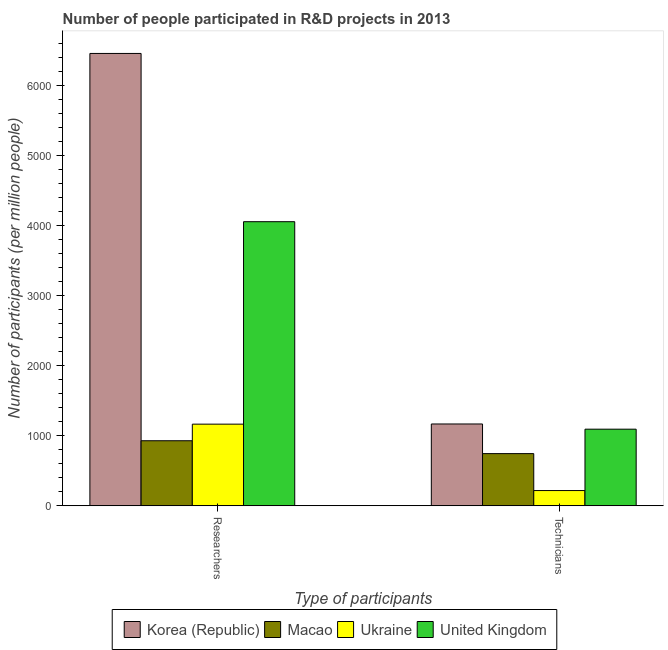How many different coloured bars are there?
Provide a succinct answer. 4. How many groups of bars are there?
Your answer should be compact. 2. How many bars are there on the 1st tick from the left?
Offer a terse response. 4. How many bars are there on the 1st tick from the right?
Keep it short and to the point. 4. What is the label of the 1st group of bars from the left?
Offer a terse response. Researchers. What is the number of researchers in Korea (Republic)?
Your answer should be very brief. 6456.63. Across all countries, what is the maximum number of researchers?
Provide a succinct answer. 6456.63. Across all countries, what is the minimum number of researchers?
Offer a very short reply. 928.25. In which country was the number of technicians minimum?
Provide a short and direct response. Ukraine. What is the total number of technicians in the graph?
Ensure brevity in your answer.  3223.07. What is the difference between the number of technicians in Macao and that in United Kingdom?
Your response must be concise. -348.83. What is the difference between the number of researchers in Ukraine and the number of technicians in United Kingdom?
Offer a very short reply. 71.71. What is the average number of researchers per country?
Offer a terse response. 3151.29. What is the difference between the number of researchers and number of technicians in United Kingdom?
Provide a short and direct response. 2961.63. In how many countries, is the number of researchers greater than 2600 ?
Make the answer very short. 2. What is the ratio of the number of technicians in Macao to that in Korea (Republic)?
Provide a short and direct response. 0.64. Is the number of researchers in Ukraine less than that in Macao?
Offer a terse response. No. In how many countries, is the number of researchers greater than the average number of researchers taken over all countries?
Provide a short and direct response. 2. What does the 4th bar from the left in Researchers represents?
Your response must be concise. United Kingdom. What does the 2nd bar from the right in Technicians represents?
Your response must be concise. Ukraine. How many bars are there?
Make the answer very short. 8. Are the values on the major ticks of Y-axis written in scientific E-notation?
Provide a succinct answer. No. Does the graph contain any zero values?
Your answer should be very brief. No. Does the graph contain grids?
Provide a succinct answer. No. Where does the legend appear in the graph?
Provide a succinct answer. Bottom center. How many legend labels are there?
Ensure brevity in your answer.  4. How are the legend labels stacked?
Offer a very short reply. Horizontal. What is the title of the graph?
Offer a terse response. Number of people participated in R&D projects in 2013. Does "Japan" appear as one of the legend labels in the graph?
Offer a very short reply. No. What is the label or title of the X-axis?
Offer a very short reply. Type of participants. What is the label or title of the Y-axis?
Offer a very short reply. Number of participants (per million people). What is the Number of participants (per million people) in Korea (Republic) in Researchers?
Your response must be concise. 6456.63. What is the Number of participants (per million people) in Macao in Researchers?
Offer a very short reply. 928.25. What is the Number of participants (per million people) of Ukraine in Researchers?
Make the answer very short. 1165.18. What is the Number of participants (per million people) of United Kingdom in Researchers?
Ensure brevity in your answer.  4055.1. What is the Number of participants (per million people) of Korea (Republic) in Technicians?
Provide a short and direct response. 1167.72. What is the Number of participants (per million people) of Macao in Technicians?
Keep it short and to the point. 744.64. What is the Number of participants (per million people) of Ukraine in Technicians?
Your answer should be compact. 217.23. What is the Number of participants (per million people) in United Kingdom in Technicians?
Offer a very short reply. 1093.47. Across all Type of participants, what is the maximum Number of participants (per million people) of Korea (Republic)?
Your response must be concise. 6456.63. Across all Type of participants, what is the maximum Number of participants (per million people) of Macao?
Provide a short and direct response. 928.25. Across all Type of participants, what is the maximum Number of participants (per million people) in Ukraine?
Your answer should be very brief. 1165.18. Across all Type of participants, what is the maximum Number of participants (per million people) in United Kingdom?
Give a very brief answer. 4055.1. Across all Type of participants, what is the minimum Number of participants (per million people) of Korea (Republic)?
Provide a succinct answer. 1167.72. Across all Type of participants, what is the minimum Number of participants (per million people) in Macao?
Ensure brevity in your answer.  744.64. Across all Type of participants, what is the minimum Number of participants (per million people) of Ukraine?
Your answer should be very brief. 217.23. Across all Type of participants, what is the minimum Number of participants (per million people) in United Kingdom?
Provide a short and direct response. 1093.47. What is the total Number of participants (per million people) of Korea (Republic) in the graph?
Ensure brevity in your answer.  7624.35. What is the total Number of participants (per million people) of Macao in the graph?
Give a very brief answer. 1672.9. What is the total Number of participants (per million people) in Ukraine in the graph?
Offer a very short reply. 1382.42. What is the total Number of participants (per million people) in United Kingdom in the graph?
Your answer should be compact. 5148.57. What is the difference between the Number of participants (per million people) in Korea (Republic) in Researchers and that in Technicians?
Ensure brevity in your answer.  5288.91. What is the difference between the Number of participants (per million people) of Macao in Researchers and that in Technicians?
Offer a very short reply. 183.61. What is the difference between the Number of participants (per million people) of Ukraine in Researchers and that in Technicians?
Offer a terse response. 947.95. What is the difference between the Number of participants (per million people) of United Kingdom in Researchers and that in Technicians?
Keep it short and to the point. 2961.63. What is the difference between the Number of participants (per million people) in Korea (Republic) in Researchers and the Number of participants (per million people) in Macao in Technicians?
Make the answer very short. 5711.98. What is the difference between the Number of participants (per million people) in Korea (Republic) in Researchers and the Number of participants (per million people) in Ukraine in Technicians?
Your response must be concise. 6239.39. What is the difference between the Number of participants (per million people) of Korea (Republic) in Researchers and the Number of participants (per million people) of United Kingdom in Technicians?
Offer a very short reply. 5363.16. What is the difference between the Number of participants (per million people) in Macao in Researchers and the Number of participants (per million people) in Ukraine in Technicians?
Offer a terse response. 711.02. What is the difference between the Number of participants (per million people) of Macao in Researchers and the Number of participants (per million people) of United Kingdom in Technicians?
Provide a succinct answer. -165.22. What is the difference between the Number of participants (per million people) in Ukraine in Researchers and the Number of participants (per million people) in United Kingdom in Technicians?
Offer a very short reply. 71.71. What is the average Number of participants (per million people) in Korea (Republic) per Type of participants?
Provide a short and direct response. 3812.17. What is the average Number of participants (per million people) of Macao per Type of participants?
Your response must be concise. 836.45. What is the average Number of participants (per million people) in Ukraine per Type of participants?
Your answer should be compact. 691.21. What is the average Number of participants (per million people) of United Kingdom per Type of participants?
Provide a succinct answer. 2574.29. What is the difference between the Number of participants (per million people) of Korea (Republic) and Number of participants (per million people) of Macao in Researchers?
Make the answer very short. 5528.37. What is the difference between the Number of participants (per million people) in Korea (Republic) and Number of participants (per million people) in Ukraine in Researchers?
Make the answer very short. 5291.44. What is the difference between the Number of participants (per million people) in Korea (Republic) and Number of participants (per million people) in United Kingdom in Researchers?
Offer a terse response. 2401.53. What is the difference between the Number of participants (per million people) in Macao and Number of participants (per million people) in Ukraine in Researchers?
Offer a terse response. -236.93. What is the difference between the Number of participants (per million people) in Macao and Number of participants (per million people) in United Kingdom in Researchers?
Offer a terse response. -3126.85. What is the difference between the Number of participants (per million people) of Ukraine and Number of participants (per million people) of United Kingdom in Researchers?
Keep it short and to the point. -2889.92. What is the difference between the Number of participants (per million people) in Korea (Republic) and Number of participants (per million people) in Macao in Technicians?
Offer a very short reply. 423.07. What is the difference between the Number of participants (per million people) of Korea (Republic) and Number of participants (per million people) of Ukraine in Technicians?
Provide a succinct answer. 950.49. What is the difference between the Number of participants (per million people) in Korea (Republic) and Number of participants (per million people) in United Kingdom in Technicians?
Offer a very short reply. 74.25. What is the difference between the Number of participants (per million people) of Macao and Number of participants (per million people) of Ukraine in Technicians?
Keep it short and to the point. 527.41. What is the difference between the Number of participants (per million people) of Macao and Number of participants (per million people) of United Kingdom in Technicians?
Provide a succinct answer. -348.83. What is the difference between the Number of participants (per million people) in Ukraine and Number of participants (per million people) in United Kingdom in Technicians?
Provide a succinct answer. -876.24. What is the ratio of the Number of participants (per million people) in Korea (Republic) in Researchers to that in Technicians?
Provide a short and direct response. 5.53. What is the ratio of the Number of participants (per million people) in Macao in Researchers to that in Technicians?
Keep it short and to the point. 1.25. What is the ratio of the Number of participants (per million people) of Ukraine in Researchers to that in Technicians?
Your answer should be very brief. 5.36. What is the ratio of the Number of participants (per million people) of United Kingdom in Researchers to that in Technicians?
Provide a short and direct response. 3.71. What is the difference between the highest and the second highest Number of participants (per million people) in Korea (Republic)?
Make the answer very short. 5288.91. What is the difference between the highest and the second highest Number of participants (per million people) in Macao?
Your answer should be compact. 183.61. What is the difference between the highest and the second highest Number of participants (per million people) in Ukraine?
Ensure brevity in your answer.  947.95. What is the difference between the highest and the second highest Number of participants (per million people) of United Kingdom?
Provide a succinct answer. 2961.63. What is the difference between the highest and the lowest Number of participants (per million people) in Korea (Republic)?
Provide a succinct answer. 5288.91. What is the difference between the highest and the lowest Number of participants (per million people) of Macao?
Provide a short and direct response. 183.61. What is the difference between the highest and the lowest Number of participants (per million people) of Ukraine?
Provide a short and direct response. 947.95. What is the difference between the highest and the lowest Number of participants (per million people) in United Kingdom?
Ensure brevity in your answer.  2961.63. 